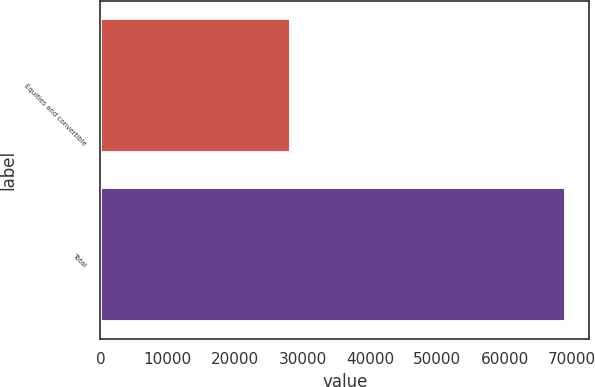<chart> <loc_0><loc_0><loc_500><loc_500><bar_chart><fcel>Equities and convertible<fcel>Total<nl><fcel>28314<fcel>69067<nl></chart> 